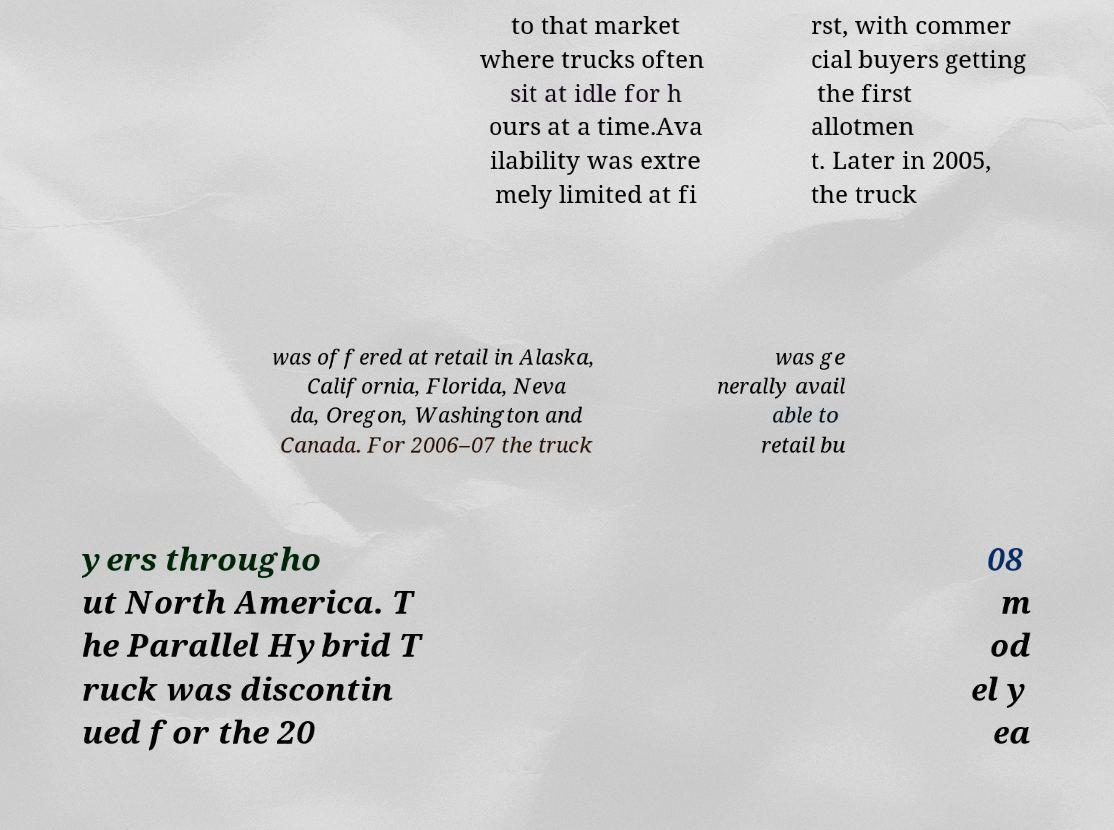Can you read and provide the text displayed in the image?This photo seems to have some interesting text. Can you extract and type it out for me? to that market where trucks often sit at idle for h ours at a time.Ava ilability was extre mely limited at fi rst, with commer cial buyers getting the first allotmen t. Later in 2005, the truck was offered at retail in Alaska, California, Florida, Neva da, Oregon, Washington and Canada. For 2006–07 the truck was ge nerally avail able to retail bu yers througho ut North America. T he Parallel Hybrid T ruck was discontin ued for the 20 08 m od el y ea 